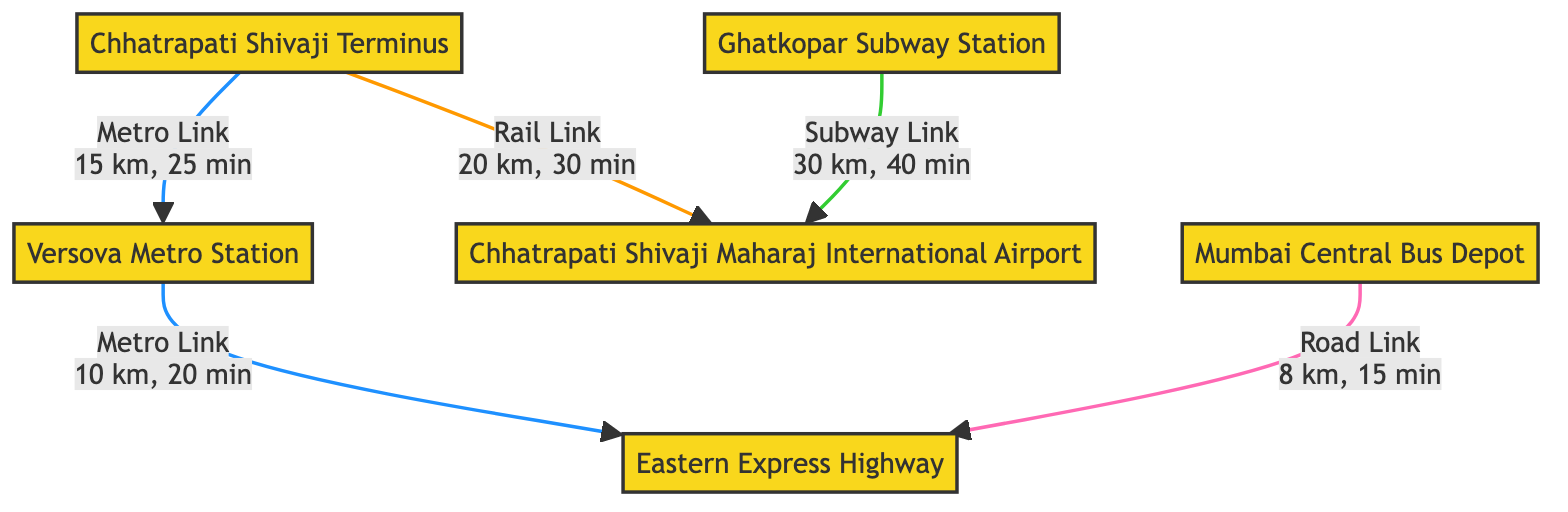What is the distance between Chhatrapati Shivaji Terminus and Chhatrapati Shivaji Maharaj International Airport? The diagram shows a Rail Link between Chhatrapati Shivaji Terminus (id: a1) and Chhatrapati Shivaji Maharaj International Airport (id: c3) with a distance of 20 km.
Answer: 20 km What type of link connects Versova Metro Station to the Eastern Express Highway? The diagram indicates that there is a Metro Link from Versova Metro Station (id: d4) to the Eastern Express Highway (id: f6).
Answer: Metro Link How many infrastructure nodes are represented in the diagram? The diagram contains six nodes labeled as infrastructure: Chhatrapati Shivaji Terminus, Mumbai Central Bus Depot, Chhatrapati Shivaji Maharaj International Airport, Versova Metro Station, Ghatkopar Subway Station, and Eastern Express Highway. Therefore, there are six infrastructure nodes.
Answer: 6 What is the total travel time from Chhatrapati Shivaji Terminus to Versova Metro Station? To find the total travel time, first, there is a travel time of 25 minutes from Chhatrapati Shivaji Terminus (a1) to Versova Metro Station (d4) directly. Thus, the total travel time is 25 minutes.
Answer: 25 minutes How long does it take to travel from Ghatkopar Subway Station to Chhatrapati Shivaji Maharaj International Airport? The diagram shows that Ghatkopar Subway Station (id: e5) connects to Chhatrapati Shivaji Maharaj International Airport (id: c3) through a Subway Link with a travel time of 40 minutes.
Answer: 40 minutes What is the shortest distance to reach the Eastern Express Highway from Mumbai Central Bus Depot? The diagram specifies that the distance from Mumbai Central Bus Depot (id: b2) to Eastern Express Highway (id: f6) by Road Link is 8 km, which is the only direct connection listed for the bus depot to the highway.
Answer: 8 km What is the travel time from Versova Metro Station to the Eastern Express Highway? According to the diagram, the travel time from Versova Metro Station (d4) to Eastern Express Highway (f6) via Metro Link is 20 minutes, and this is the only direct connection given from Versova to the highway.
Answer: 20 minutes Which node has the highest travel time to reach another infrastructure node based on the given connections? Evaluating the connections, the longest travel time is from Ghatkopar Subway Station (e5) to Chhatrapati Shivaji Maharaj International Airport (c3) via Subway Link, which takes 40 minutes.
Answer: 40 minutes 